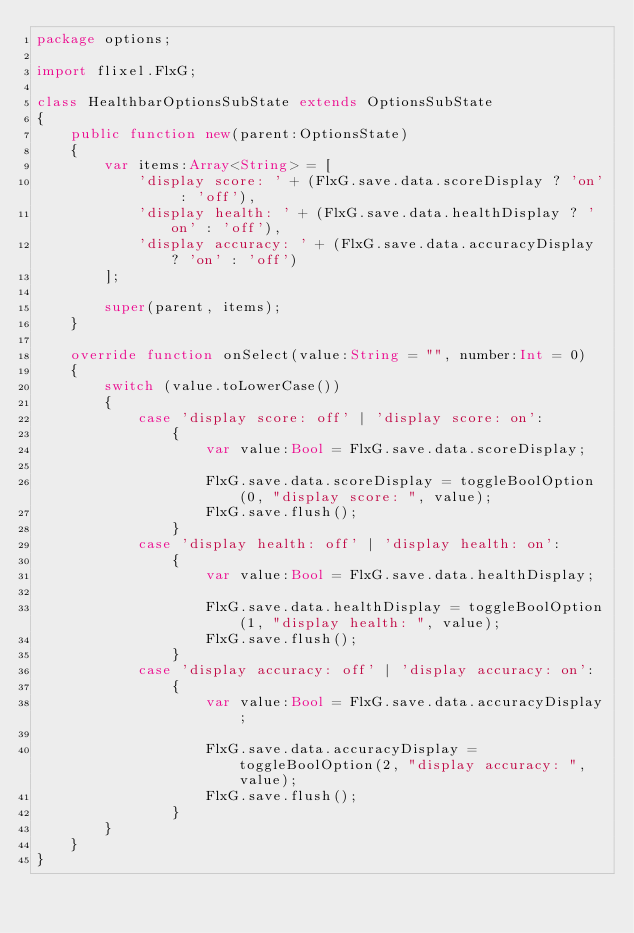Convert code to text. <code><loc_0><loc_0><loc_500><loc_500><_Haxe_>package options;

import flixel.FlxG;

class HealthbarOptionsSubState extends OptionsSubState
{
	public function new(parent:OptionsState)
	{
		var items:Array<String> = [
			'display score: ' + (FlxG.save.data.scoreDisplay ? 'on' : 'off'),
			'display health: ' + (FlxG.save.data.healthDisplay ? 'on' : 'off'),
			'display accuracy: ' + (FlxG.save.data.accuracyDisplay ? 'on' : 'off')
		];

		super(parent, items);
	}

	override function onSelect(value:String = "", number:Int = 0)
	{
		switch (value.toLowerCase())
		{
			case 'display score: off' | 'display score: on':
				{
					var value:Bool = FlxG.save.data.scoreDisplay;

					FlxG.save.data.scoreDisplay = toggleBoolOption(0, "display score: ", value);
					FlxG.save.flush();
				}
			case 'display health: off' | 'display health: on':
				{
					var value:Bool = FlxG.save.data.healthDisplay;

					FlxG.save.data.healthDisplay = toggleBoolOption(1, "display health: ", value);
					FlxG.save.flush();
				}
			case 'display accuracy: off' | 'display accuracy: on':
				{
					var value:Bool = FlxG.save.data.accuracyDisplay;

					FlxG.save.data.accuracyDisplay = toggleBoolOption(2, "display accuracy: ", value);
					FlxG.save.flush();
				}
		}
	}
}
</code> 